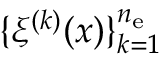Convert formula to latex. <formula><loc_0><loc_0><loc_500><loc_500>\{ \xi ^ { ( k ) } ( x ) \} _ { k = 1 } ^ { n _ { e } }</formula> 